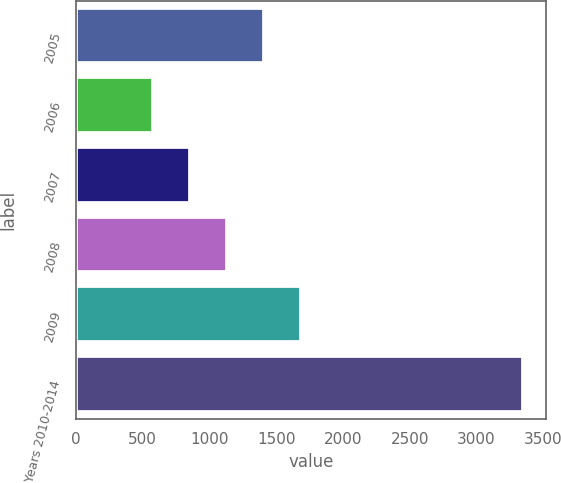Convert chart to OTSL. <chart><loc_0><loc_0><loc_500><loc_500><bar_chart><fcel>2005<fcel>2006<fcel>2007<fcel>2008<fcel>2009<fcel>Years 2010-2014<nl><fcel>1410.2<fcel>578<fcel>855.4<fcel>1132.8<fcel>1687.6<fcel>3352<nl></chart> 